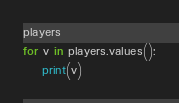Convert code to text. <code><loc_0><loc_0><loc_500><loc_500><_Python_>players
for v in players.values():
    print(v)</code> 